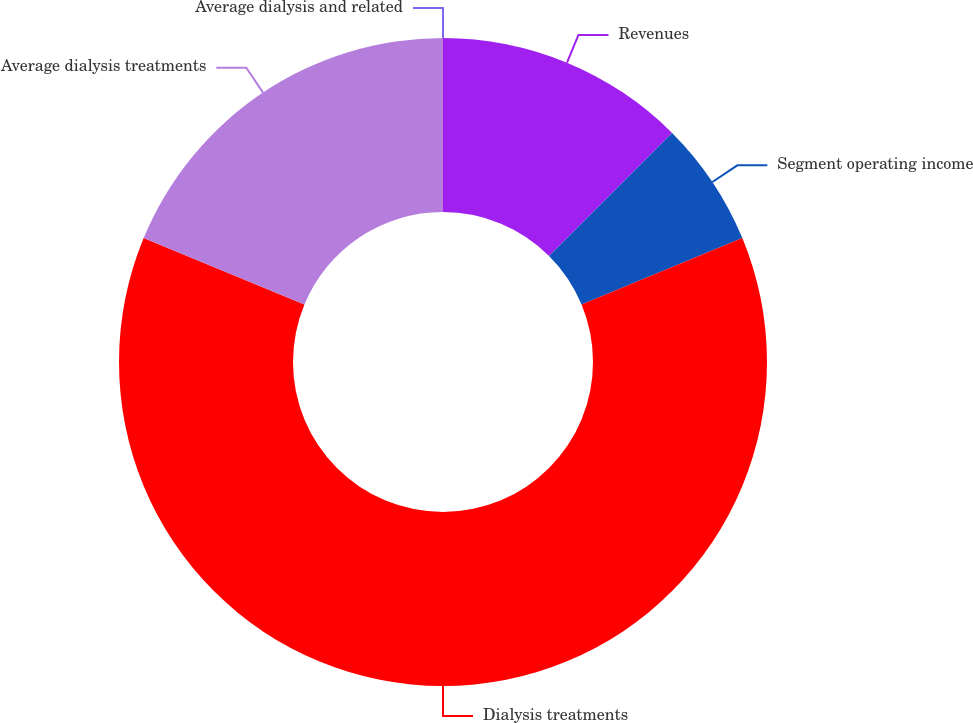<chart> <loc_0><loc_0><loc_500><loc_500><pie_chart><fcel>Revenues<fcel>Segment operating income<fcel>Dialysis treatments<fcel>Average dialysis treatments<fcel>Average dialysis and related<nl><fcel>12.5%<fcel>6.25%<fcel>62.5%<fcel>18.75%<fcel>0.0%<nl></chart> 